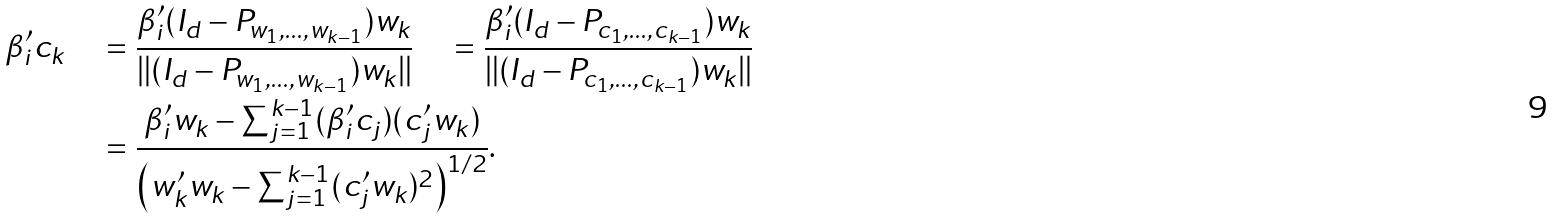<formula> <loc_0><loc_0><loc_500><loc_500>\beta _ { i } ^ { \prime } c _ { k } \quad & = \frac { \beta _ { i } ^ { \prime } ( I _ { d } - P _ { w _ { 1 } , \dots , w _ { k - 1 } } ) w _ { k } } { \| ( I _ { d } - P _ { w _ { 1 } , \dots , w _ { k - 1 } } ) w _ { k } \| } \quad = \frac { \beta _ { i } ^ { \prime } ( I _ { d } - P _ { c _ { 1 } , \dots , c _ { k - 1 } } ) w _ { k } } { \| ( I _ { d } - P _ { c _ { 1 } , \dots , c _ { k - 1 } } ) w _ { k } \| } \\ & = \frac { \beta _ { i } ^ { \prime } w _ { k } - \sum _ { j = 1 } ^ { k - 1 } ( \beta _ { i } ^ { \prime } c _ { j } ) ( c _ { j } ^ { \prime } w _ { k } ) } { \left ( w _ { k } ^ { \prime } w _ { k } - \sum _ { j = 1 } ^ { k - 1 } ( c _ { j } ^ { \prime } w _ { k } ) ^ { 2 } \right ) ^ { 1 / 2 } } .</formula> 